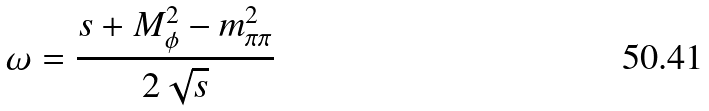<formula> <loc_0><loc_0><loc_500><loc_500>\omega = \frac { s + M _ { \phi } ^ { 2 } - m _ { \pi \pi } ^ { 2 } } { 2 \sqrt { s } }</formula> 